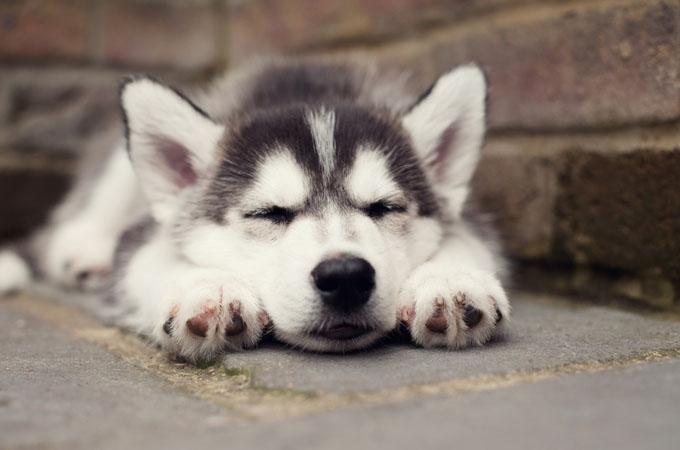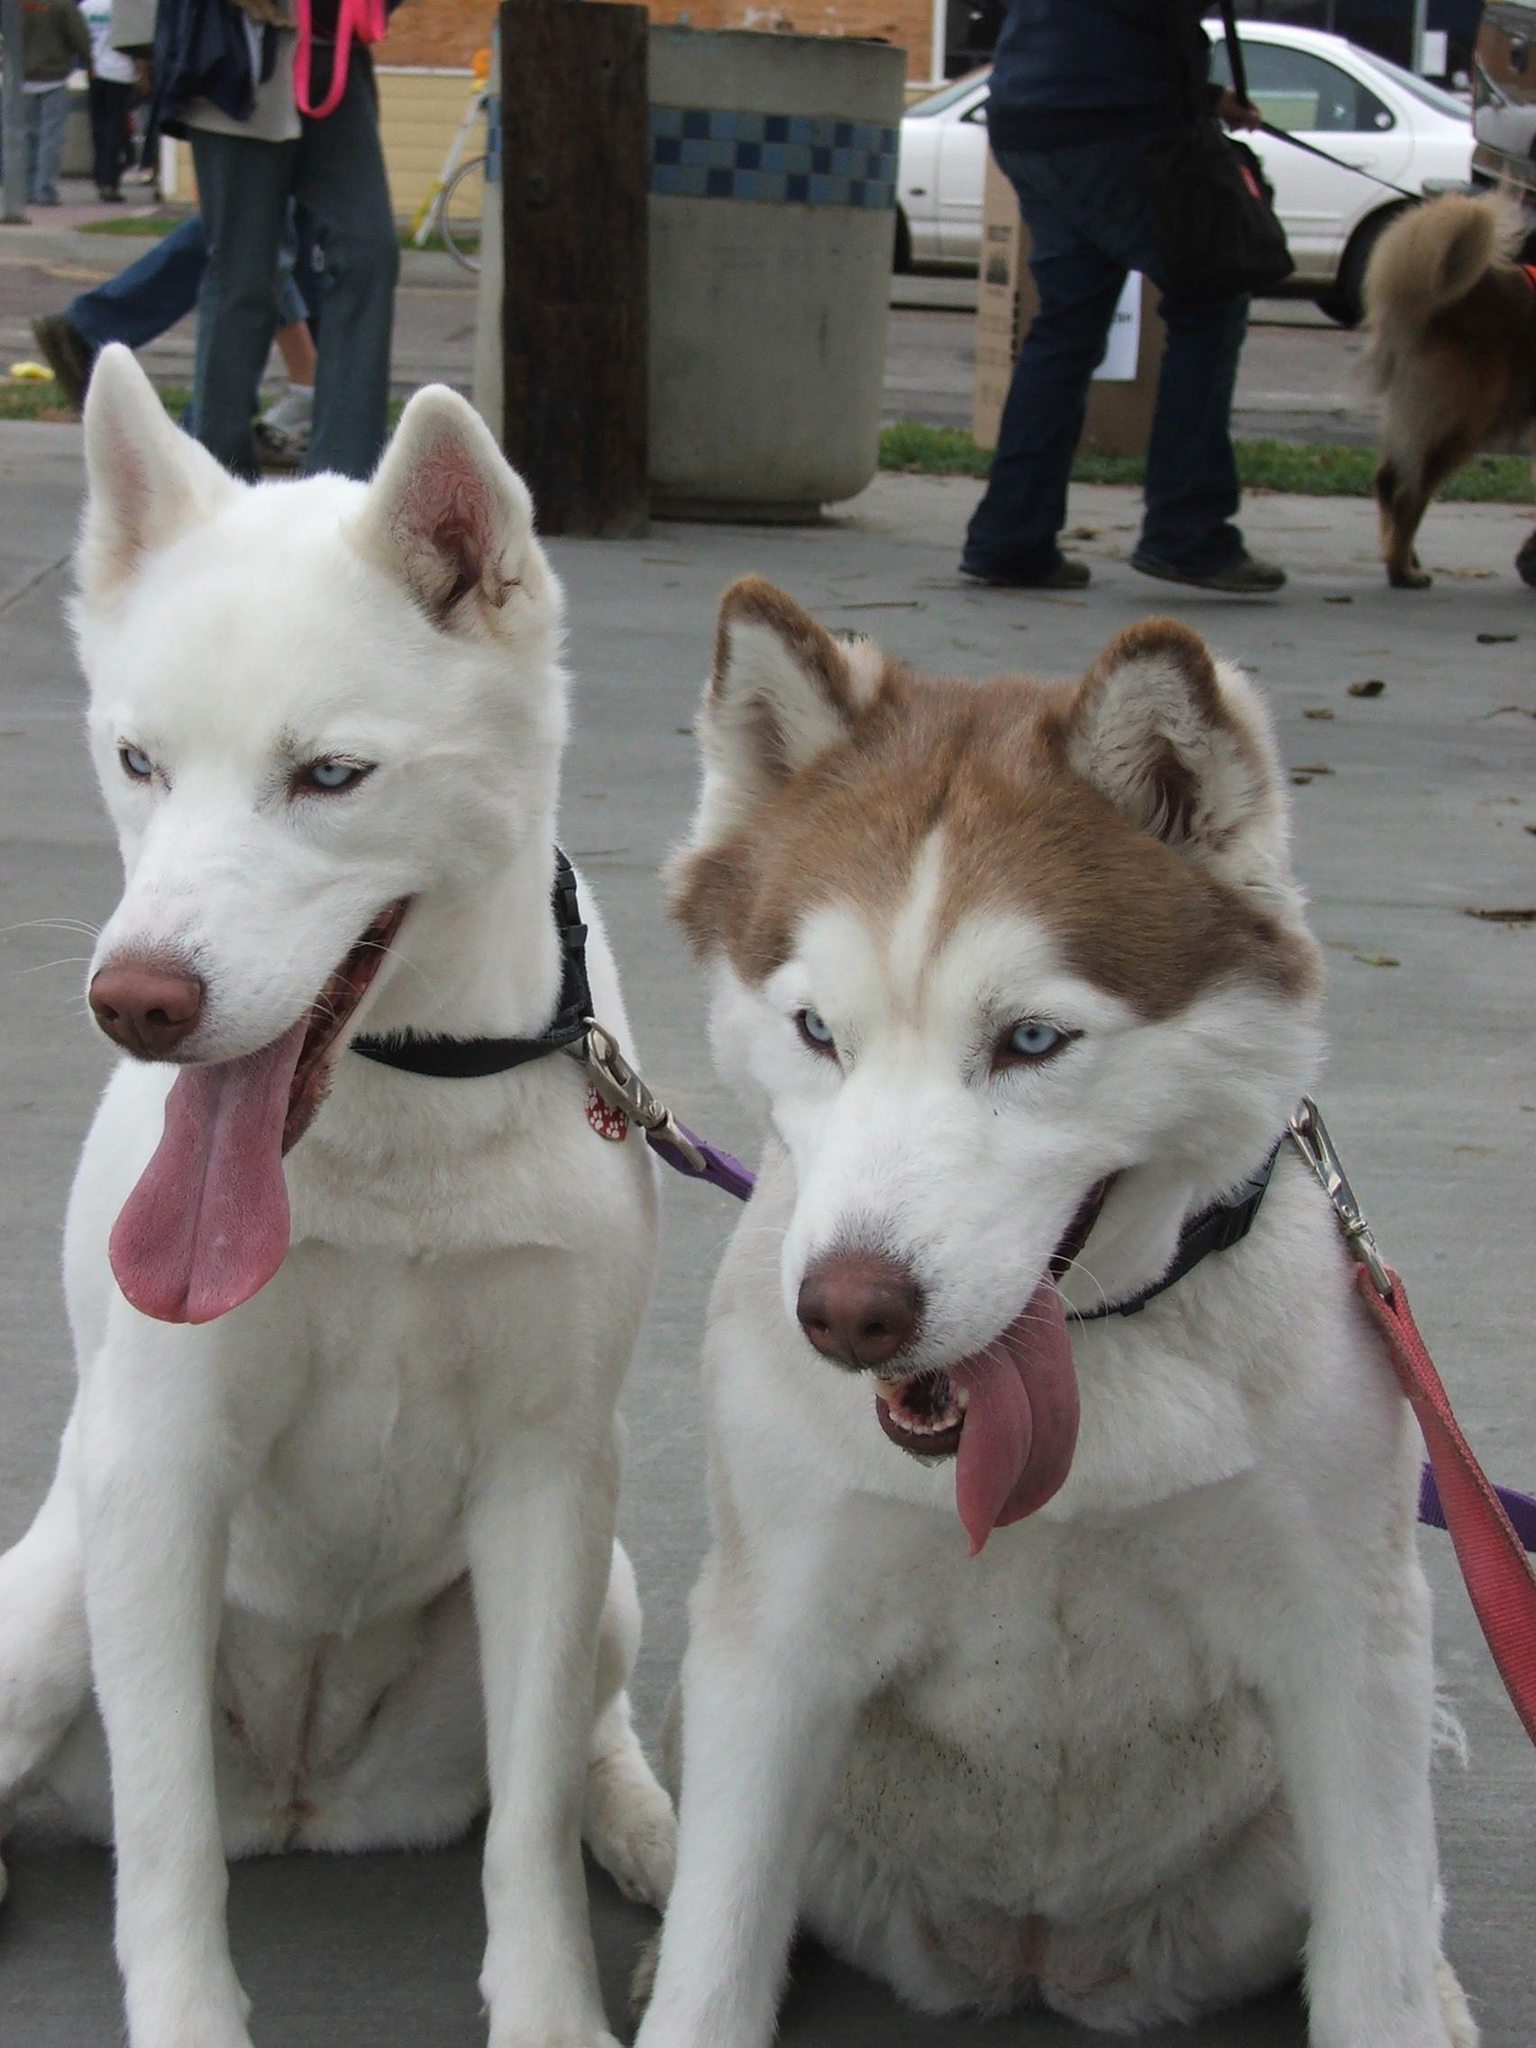The first image is the image on the left, the second image is the image on the right. Examine the images to the left and right. Is the description "There are five grey headed husky puppies next to each other." accurate? Answer yes or no. No. The first image is the image on the left, the second image is the image on the right. Considering the images on both sides, is "One of the images contains two dogs with their mouths open." valid? Answer yes or no. Yes. 